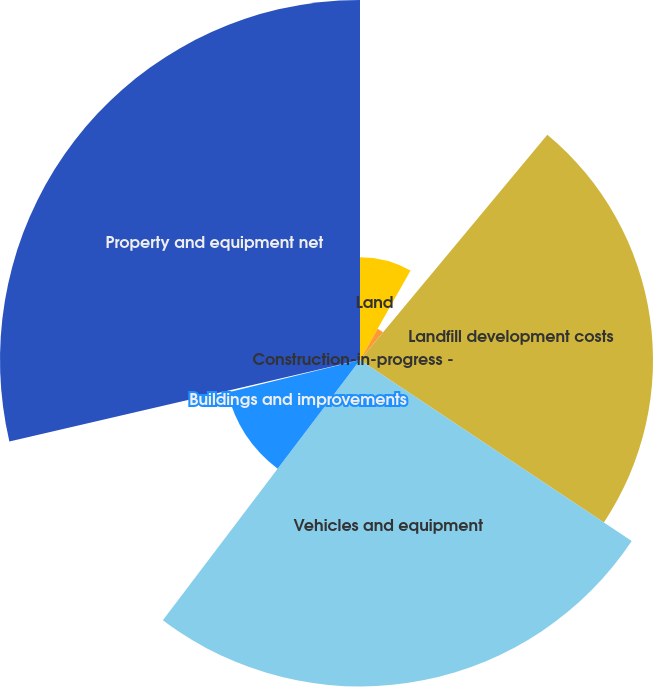<chart> <loc_0><loc_0><loc_500><loc_500><pie_chart><fcel>Land<fcel>Non-depletable landfill land<fcel>Landfill development costs<fcel>Vehicles and equipment<fcel>Buildings and improvements<fcel>Construction-in-progress -<fcel>Property and equipment net<nl><fcel>8.18%<fcel>2.86%<fcel>23.31%<fcel>25.97%<fcel>10.85%<fcel>0.19%<fcel>28.64%<nl></chart> 